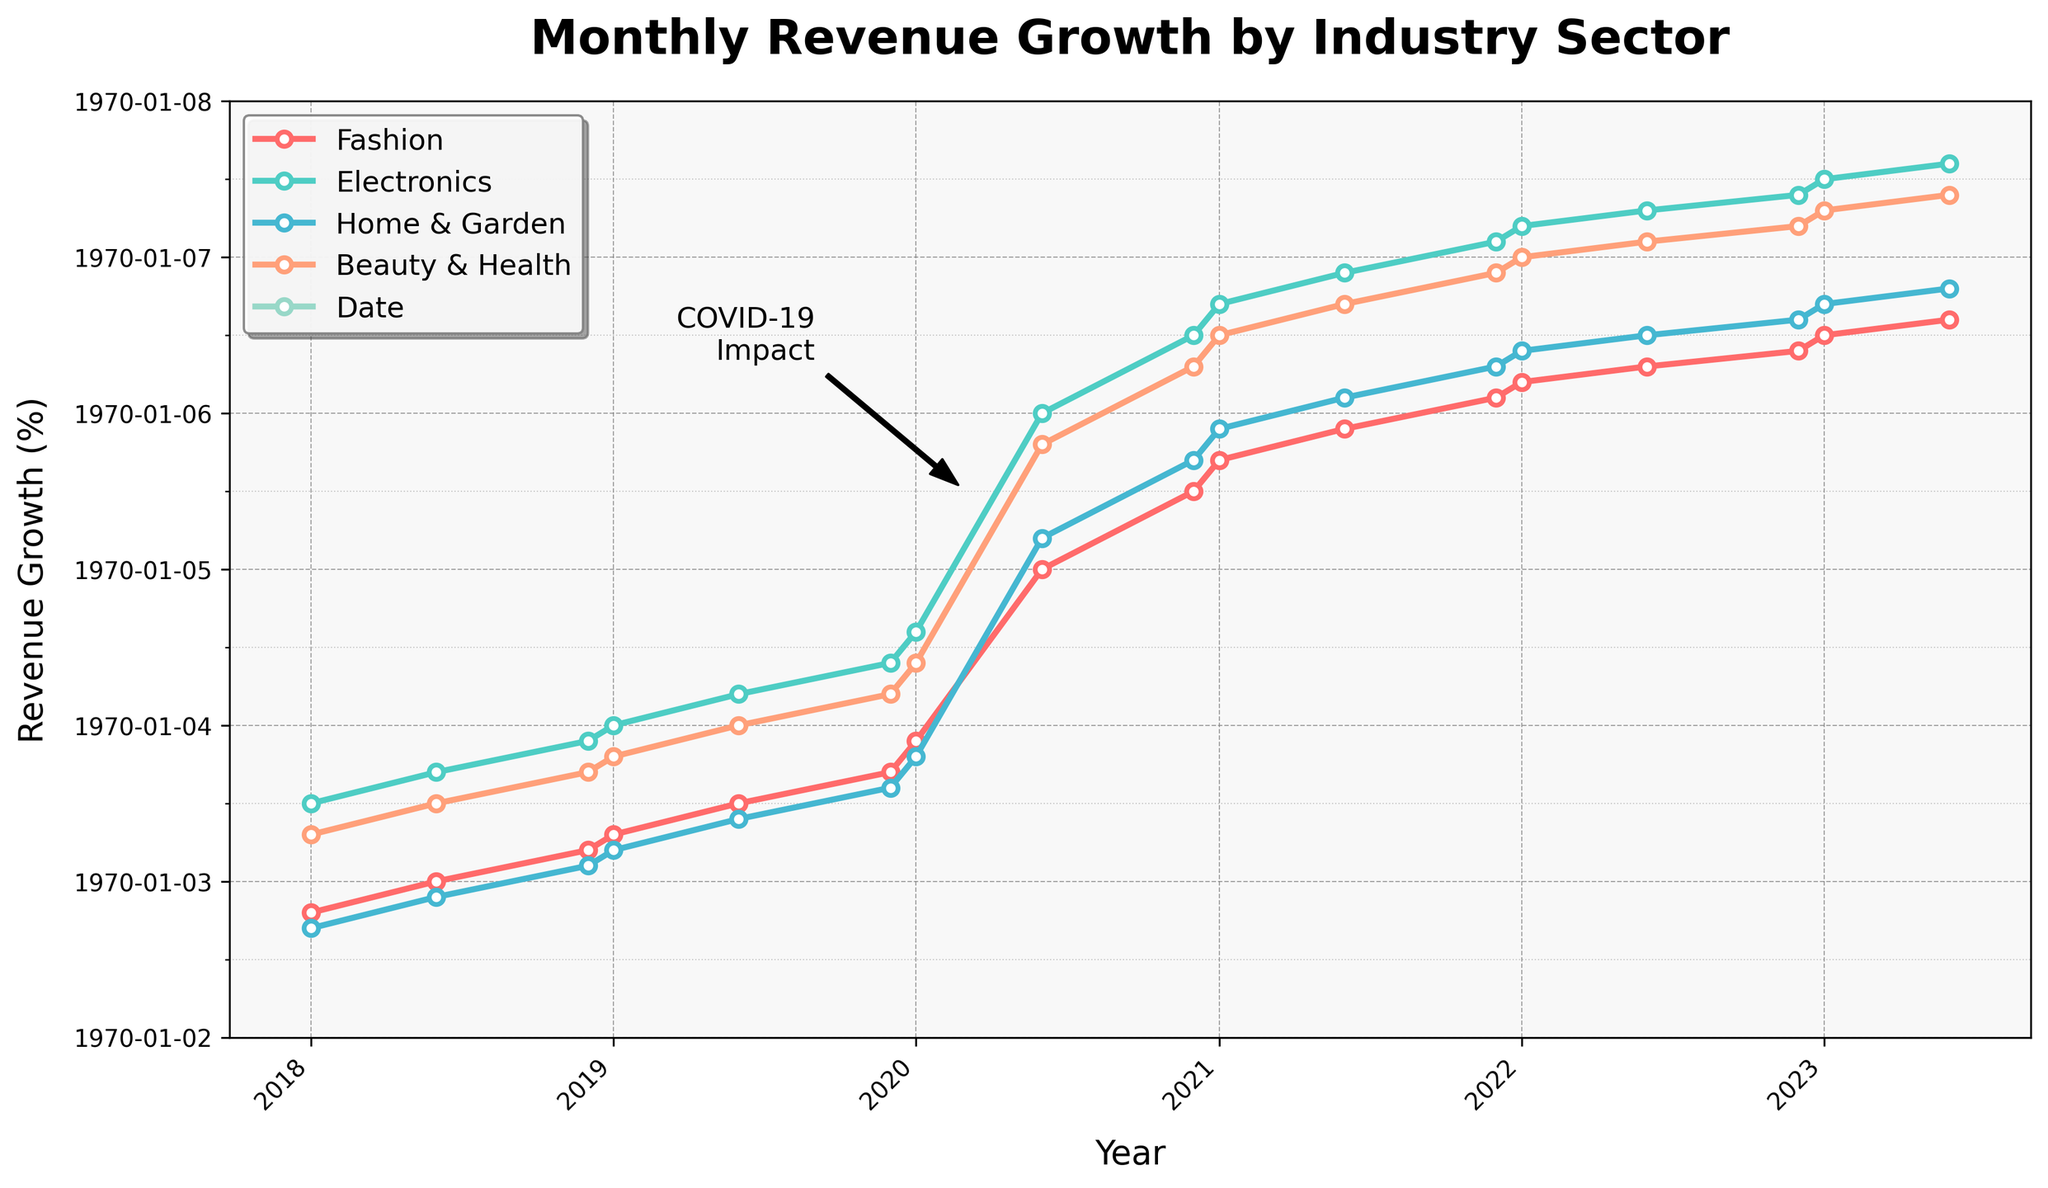Which industry sector saw the largest revenue growth during the pandemic period around 2020-03-01? First, identify the revenue growth for each sector around March 2020 and then check the increase after that period. Electronics grew from 3.6 in January 2020 to 5.0 in June 2020, showing the largest increase.
Answer: Electronics How does the revenue growth of Retail in June 2023 compare to Fashion in the same month? In June 2023, the Retail sector has a revenue growth of 6.1, while the Fashion sector has 5.6. Comparing these values, Retail's revenue growth is higher.
Answer: Retail is higher What visual attribute identifies the Electronics sector on the chart? Look at the colors assigned to each sector in the chart. The Electronics sector is represented by a blue-colored line.
Answer: Blue Which two industry sectors have the most similar revenue growth trends over the 5 years? Visually inspect the trend lines for all sectors to see which two are closest together. Beauty & Health and Fashion have very similar trends, closely following each other throughout the period.
Answer: Beauty & Health and Fashion By how much did the Home & Garden sector's revenue growth change from January 2020 to January 2021? Home & Garden’s revenue growth in January 2020 was 2.8, and in January 2021, it was 4.9. Calculate the difference: 4.9 - 2.8 = 2.1.
Answer: 2.1 What is the average revenue growth of the Fashion sector for the year 2023 (January and June)? Find the values for Fashion in January 2023 (5.5) and June 2023 (5.6), then calculate the average: (5.5 + 5.6) / 2 = 5.55.
Answer: 5.55 Which two points in time show the highest revenue growth spike for the Retail sector? Look for the largest vertical increase in the Retail line over short time periods. The biggest spike occurs between January 2020 (3.2) and June 2020 (4.5).
Answer: January 2020 to June 2020 Between January 2018 and January 2023, by how much did the Beauty & Health sector's revenue growth increase? Beauty & Health’s revenue growth in January 2018 was 2.3, and in January 2023, it was 6.3. Calculate the difference: 6.3 - 2.3 = 4.
Answer: 4 